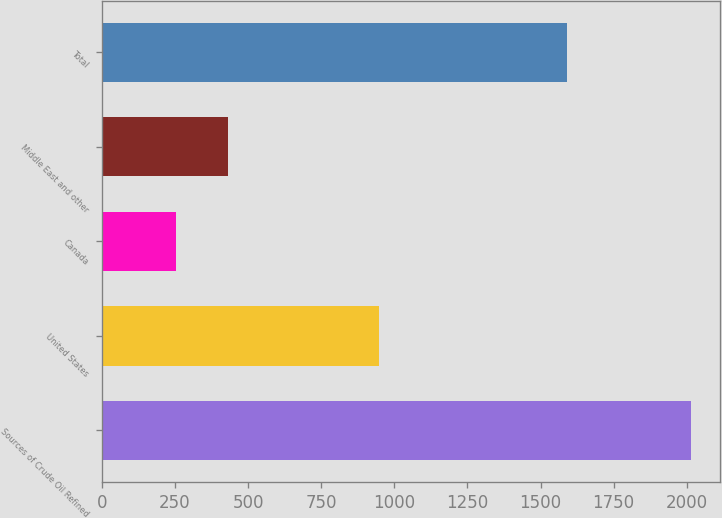<chart> <loc_0><loc_0><loc_500><loc_500><bar_chart><fcel>Sources of Crude Oil Refined<fcel>United States<fcel>Canada<fcel>Middle East and other<fcel>Total<nl><fcel>2013<fcel>946<fcel>255<fcel>430.8<fcel>1589<nl></chart> 